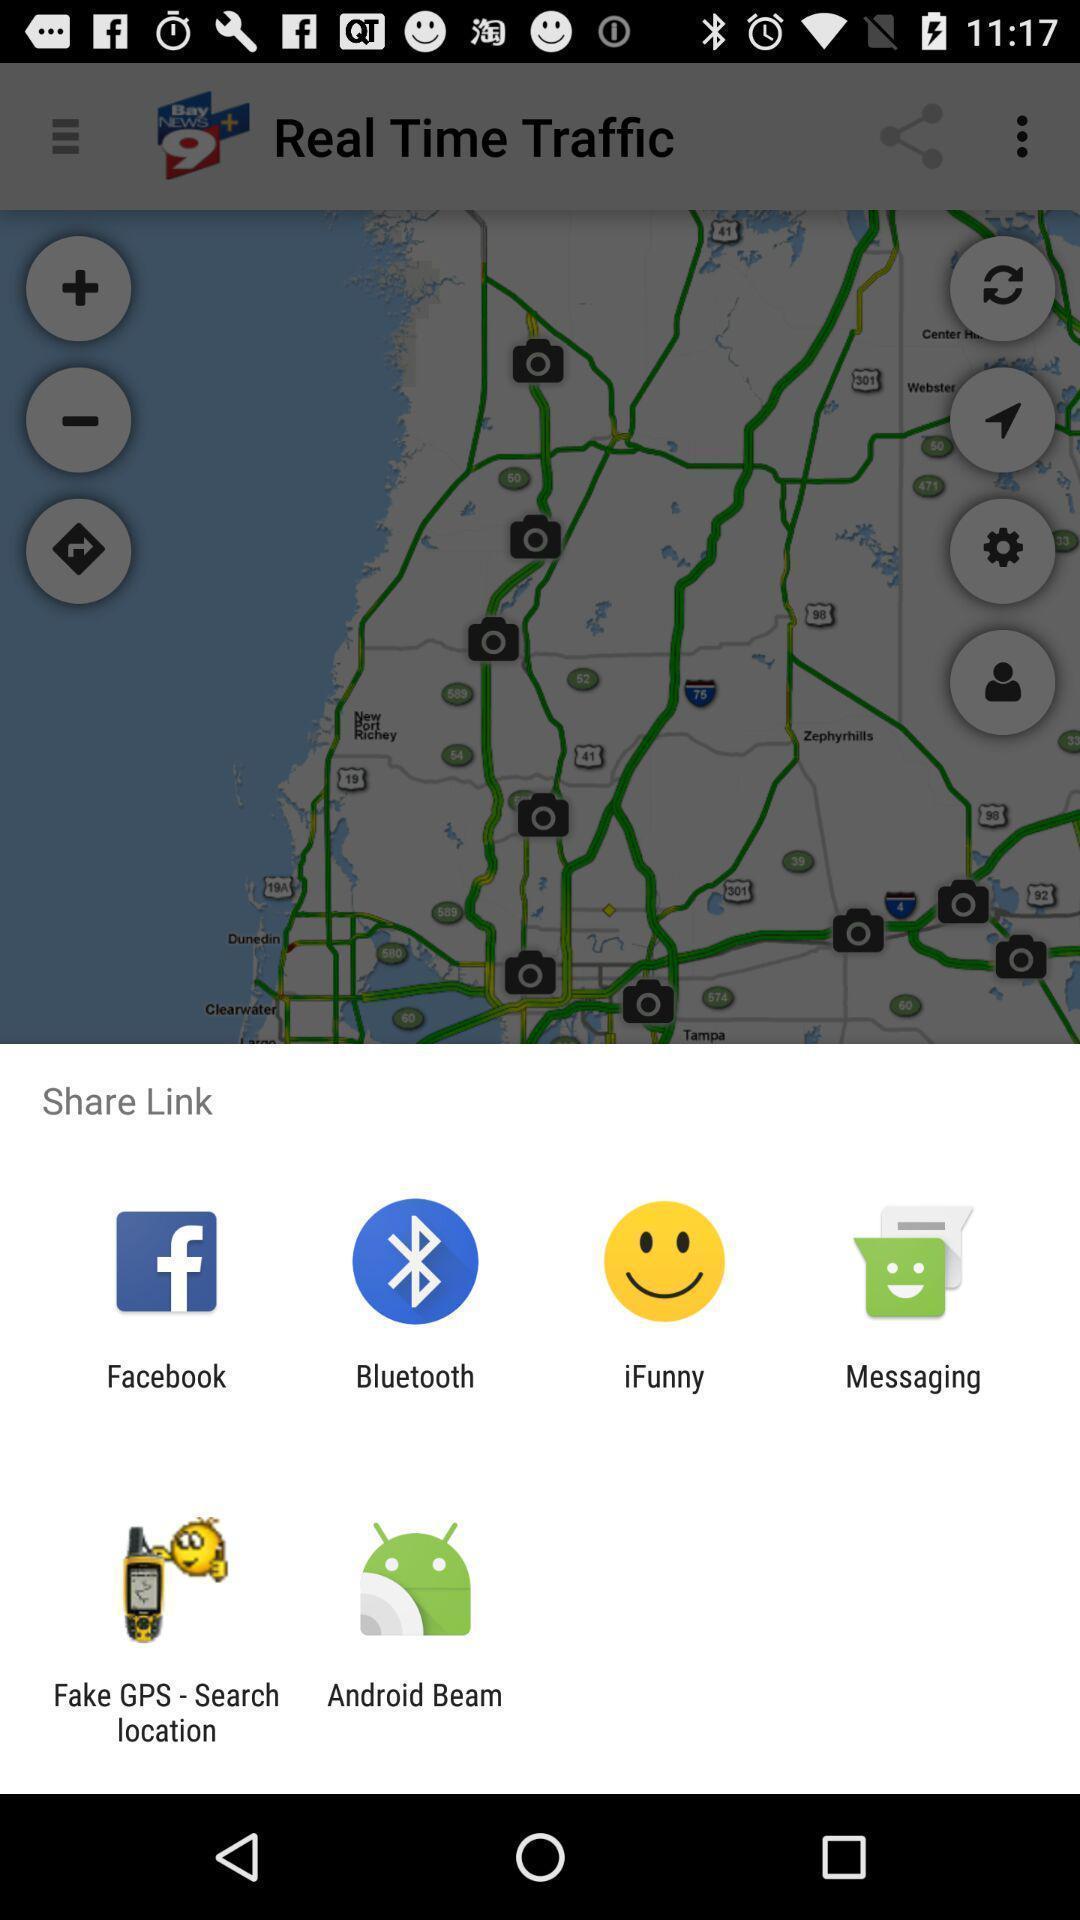Tell me what you see in this picture. Push up page displaying to share link via social application. 